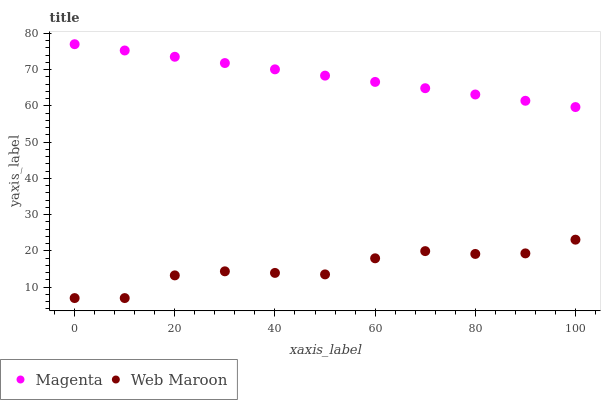Does Web Maroon have the minimum area under the curve?
Answer yes or no. Yes. Does Magenta have the maximum area under the curve?
Answer yes or no. Yes. Does Web Maroon have the maximum area under the curve?
Answer yes or no. No. Is Magenta the smoothest?
Answer yes or no. Yes. Is Web Maroon the roughest?
Answer yes or no. Yes. Is Web Maroon the smoothest?
Answer yes or no. No. Does Web Maroon have the lowest value?
Answer yes or no. Yes. Does Magenta have the highest value?
Answer yes or no. Yes. Does Web Maroon have the highest value?
Answer yes or no. No. Is Web Maroon less than Magenta?
Answer yes or no. Yes. Is Magenta greater than Web Maroon?
Answer yes or no. Yes. Does Web Maroon intersect Magenta?
Answer yes or no. No. 